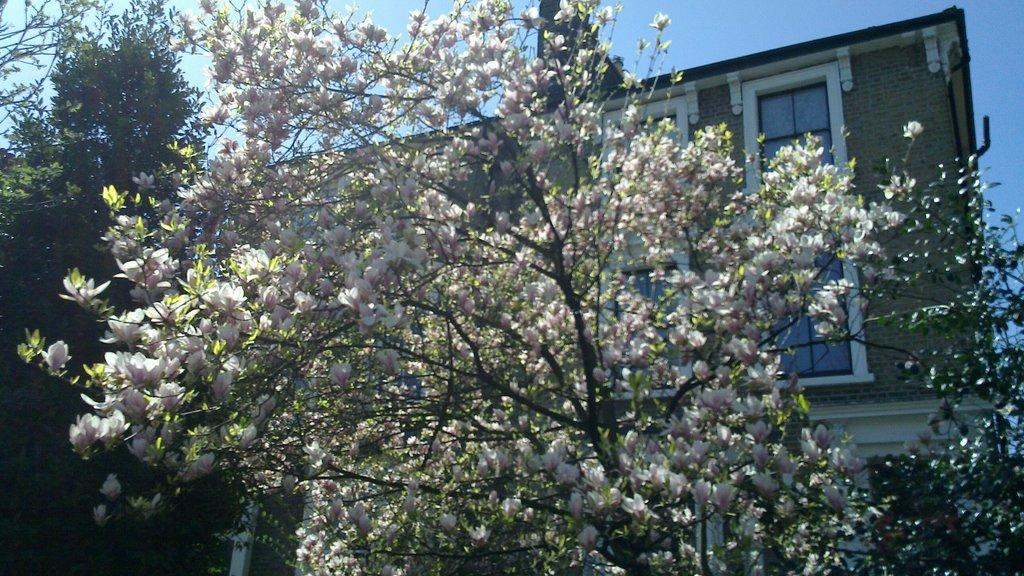What is located in the center of the image? There are trees in the center of the image. What can be seen in the background of the image? There is a building in the background area of the image. What type of feeling is expressed by the trees in the image? Trees do not express feelings, so this question cannot be answered based on the image. 